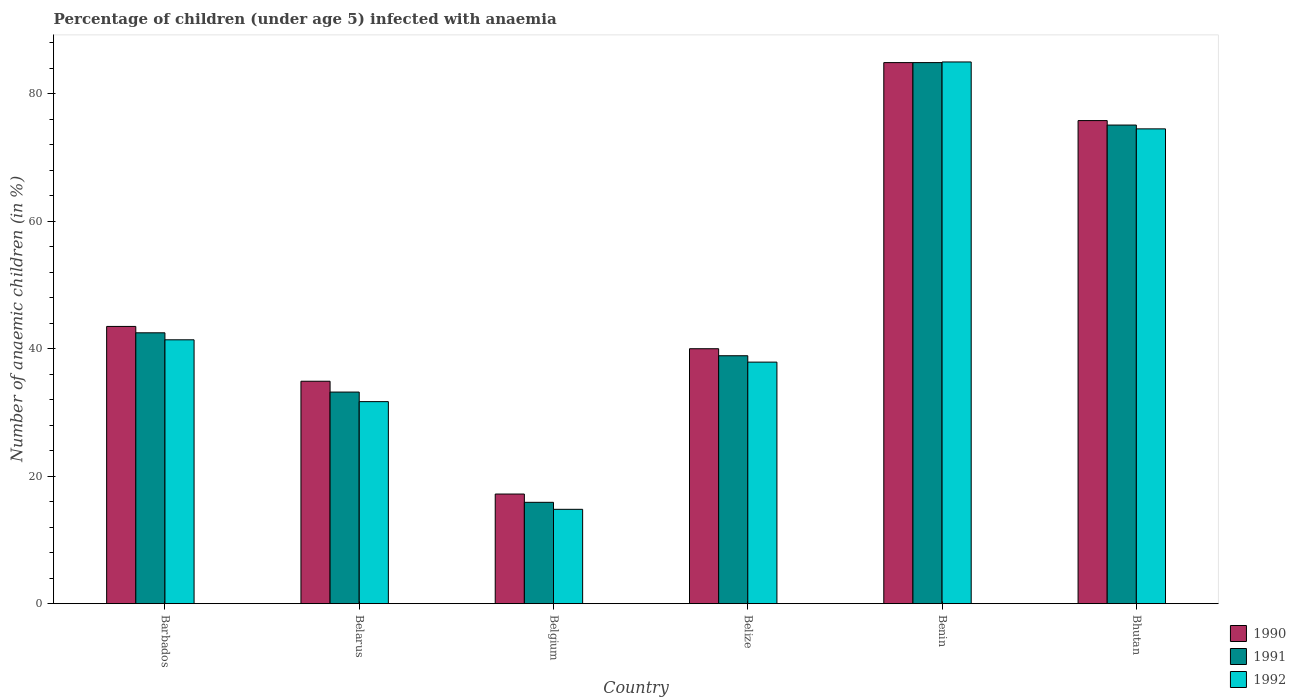How many different coloured bars are there?
Provide a short and direct response. 3. How many groups of bars are there?
Offer a very short reply. 6. Are the number of bars per tick equal to the number of legend labels?
Offer a terse response. Yes. How many bars are there on the 4th tick from the left?
Offer a terse response. 3. How many bars are there on the 4th tick from the right?
Your answer should be compact. 3. What is the label of the 2nd group of bars from the left?
Provide a succinct answer. Belarus. In how many cases, is the number of bars for a given country not equal to the number of legend labels?
Your answer should be very brief. 0. What is the percentage of children infected with anaemia in in 1991 in Belarus?
Provide a short and direct response. 33.2. Across all countries, what is the maximum percentage of children infected with anaemia in in 1991?
Your answer should be compact. 84.9. Across all countries, what is the minimum percentage of children infected with anaemia in in 1992?
Make the answer very short. 14.8. In which country was the percentage of children infected with anaemia in in 1990 maximum?
Provide a short and direct response. Benin. In which country was the percentage of children infected with anaemia in in 1992 minimum?
Offer a very short reply. Belgium. What is the total percentage of children infected with anaemia in in 1992 in the graph?
Your answer should be compact. 285.3. What is the difference between the percentage of children infected with anaemia in in 1992 in Barbados and that in Belarus?
Ensure brevity in your answer.  9.7. What is the difference between the percentage of children infected with anaemia in in 1992 in Bhutan and the percentage of children infected with anaemia in in 1990 in Benin?
Your answer should be very brief. -10.4. What is the average percentage of children infected with anaemia in in 1991 per country?
Offer a terse response. 48.42. What is the difference between the percentage of children infected with anaemia in of/in 1992 and percentage of children infected with anaemia in of/in 1990 in Belgium?
Offer a terse response. -2.4. What is the ratio of the percentage of children infected with anaemia in in 1992 in Belarus to that in Bhutan?
Give a very brief answer. 0.43. What is the difference between the highest and the second highest percentage of children infected with anaemia in in 1991?
Your answer should be compact. -32.6. What is the difference between the highest and the lowest percentage of children infected with anaemia in in 1991?
Ensure brevity in your answer.  69. What does the 1st bar from the right in Benin represents?
Provide a succinct answer. 1992. How many bars are there?
Offer a very short reply. 18. Are all the bars in the graph horizontal?
Your answer should be compact. No. How many countries are there in the graph?
Your answer should be very brief. 6. Are the values on the major ticks of Y-axis written in scientific E-notation?
Your answer should be compact. No. Does the graph contain grids?
Your answer should be very brief. No. How many legend labels are there?
Offer a very short reply. 3. What is the title of the graph?
Make the answer very short. Percentage of children (under age 5) infected with anaemia. What is the label or title of the Y-axis?
Your answer should be compact. Number of anaemic children (in %). What is the Number of anaemic children (in %) of 1990 in Barbados?
Provide a short and direct response. 43.5. What is the Number of anaemic children (in %) of 1991 in Barbados?
Offer a very short reply. 42.5. What is the Number of anaemic children (in %) in 1992 in Barbados?
Your response must be concise. 41.4. What is the Number of anaemic children (in %) of 1990 in Belarus?
Provide a succinct answer. 34.9. What is the Number of anaemic children (in %) of 1991 in Belarus?
Your response must be concise. 33.2. What is the Number of anaemic children (in %) in 1992 in Belarus?
Your answer should be very brief. 31.7. What is the Number of anaemic children (in %) of 1991 in Belgium?
Offer a very short reply. 15.9. What is the Number of anaemic children (in %) of 1992 in Belgium?
Provide a succinct answer. 14.8. What is the Number of anaemic children (in %) of 1990 in Belize?
Offer a very short reply. 40. What is the Number of anaemic children (in %) in 1991 in Belize?
Provide a succinct answer. 38.9. What is the Number of anaemic children (in %) of 1992 in Belize?
Provide a succinct answer. 37.9. What is the Number of anaemic children (in %) in 1990 in Benin?
Provide a succinct answer. 84.9. What is the Number of anaemic children (in %) in 1991 in Benin?
Your answer should be compact. 84.9. What is the Number of anaemic children (in %) of 1992 in Benin?
Make the answer very short. 85. What is the Number of anaemic children (in %) in 1990 in Bhutan?
Ensure brevity in your answer.  75.8. What is the Number of anaemic children (in %) in 1991 in Bhutan?
Ensure brevity in your answer.  75.1. What is the Number of anaemic children (in %) in 1992 in Bhutan?
Give a very brief answer. 74.5. Across all countries, what is the maximum Number of anaemic children (in %) of 1990?
Provide a short and direct response. 84.9. Across all countries, what is the maximum Number of anaemic children (in %) in 1991?
Ensure brevity in your answer.  84.9. Across all countries, what is the maximum Number of anaemic children (in %) of 1992?
Your response must be concise. 85. Across all countries, what is the minimum Number of anaemic children (in %) in 1990?
Make the answer very short. 17.2. Across all countries, what is the minimum Number of anaemic children (in %) in 1991?
Offer a terse response. 15.9. What is the total Number of anaemic children (in %) of 1990 in the graph?
Keep it short and to the point. 296.3. What is the total Number of anaemic children (in %) in 1991 in the graph?
Provide a succinct answer. 290.5. What is the total Number of anaemic children (in %) of 1992 in the graph?
Keep it short and to the point. 285.3. What is the difference between the Number of anaemic children (in %) of 1991 in Barbados and that in Belarus?
Ensure brevity in your answer.  9.3. What is the difference between the Number of anaemic children (in %) of 1992 in Barbados and that in Belarus?
Your response must be concise. 9.7. What is the difference between the Number of anaemic children (in %) of 1990 in Barbados and that in Belgium?
Make the answer very short. 26.3. What is the difference between the Number of anaemic children (in %) of 1991 in Barbados and that in Belgium?
Keep it short and to the point. 26.6. What is the difference between the Number of anaemic children (in %) in 1992 in Barbados and that in Belgium?
Your answer should be compact. 26.6. What is the difference between the Number of anaemic children (in %) of 1990 in Barbados and that in Belize?
Make the answer very short. 3.5. What is the difference between the Number of anaemic children (in %) in 1991 in Barbados and that in Belize?
Your answer should be compact. 3.6. What is the difference between the Number of anaemic children (in %) of 1990 in Barbados and that in Benin?
Provide a short and direct response. -41.4. What is the difference between the Number of anaemic children (in %) in 1991 in Barbados and that in Benin?
Keep it short and to the point. -42.4. What is the difference between the Number of anaemic children (in %) in 1992 in Barbados and that in Benin?
Offer a terse response. -43.6. What is the difference between the Number of anaemic children (in %) in 1990 in Barbados and that in Bhutan?
Make the answer very short. -32.3. What is the difference between the Number of anaemic children (in %) of 1991 in Barbados and that in Bhutan?
Give a very brief answer. -32.6. What is the difference between the Number of anaemic children (in %) of 1992 in Barbados and that in Bhutan?
Offer a very short reply. -33.1. What is the difference between the Number of anaemic children (in %) of 1991 in Belarus and that in Belgium?
Provide a short and direct response. 17.3. What is the difference between the Number of anaemic children (in %) of 1990 in Belarus and that in Belize?
Make the answer very short. -5.1. What is the difference between the Number of anaemic children (in %) of 1991 in Belarus and that in Benin?
Offer a very short reply. -51.7. What is the difference between the Number of anaemic children (in %) of 1992 in Belarus and that in Benin?
Your response must be concise. -53.3. What is the difference between the Number of anaemic children (in %) of 1990 in Belarus and that in Bhutan?
Make the answer very short. -40.9. What is the difference between the Number of anaemic children (in %) in 1991 in Belarus and that in Bhutan?
Make the answer very short. -41.9. What is the difference between the Number of anaemic children (in %) in 1992 in Belarus and that in Bhutan?
Make the answer very short. -42.8. What is the difference between the Number of anaemic children (in %) of 1990 in Belgium and that in Belize?
Give a very brief answer. -22.8. What is the difference between the Number of anaemic children (in %) in 1992 in Belgium and that in Belize?
Offer a terse response. -23.1. What is the difference between the Number of anaemic children (in %) in 1990 in Belgium and that in Benin?
Provide a succinct answer. -67.7. What is the difference between the Number of anaemic children (in %) of 1991 in Belgium and that in Benin?
Provide a succinct answer. -69. What is the difference between the Number of anaemic children (in %) of 1992 in Belgium and that in Benin?
Provide a short and direct response. -70.2. What is the difference between the Number of anaemic children (in %) in 1990 in Belgium and that in Bhutan?
Offer a very short reply. -58.6. What is the difference between the Number of anaemic children (in %) in 1991 in Belgium and that in Bhutan?
Ensure brevity in your answer.  -59.2. What is the difference between the Number of anaemic children (in %) of 1992 in Belgium and that in Bhutan?
Your response must be concise. -59.7. What is the difference between the Number of anaemic children (in %) in 1990 in Belize and that in Benin?
Your answer should be compact. -44.9. What is the difference between the Number of anaemic children (in %) in 1991 in Belize and that in Benin?
Your answer should be compact. -46. What is the difference between the Number of anaemic children (in %) in 1992 in Belize and that in Benin?
Your response must be concise. -47.1. What is the difference between the Number of anaemic children (in %) in 1990 in Belize and that in Bhutan?
Offer a terse response. -35.8. What is the difference between the Number of anaemic children (in %) in 1991 in Belize and that in Bhutan?
Give a very brief answer. -36.2. What is the difference between the Number of anaemic children (in %) in 1992 in Belize and that in Bhutan?
Give a very brief answer. -36.6. What is the difference between the Number of anaemic children (in %) in 1990 in Benin and that in Bhutan?
Keep it short and to the point. 9.1. What is the difference between the Number of anaemic children (in %) of 1992 in Benin and that in Bhutan?
Offer a terse response. 10.5. What is the difference between the Number of anaemic children (in %) of 1990 in Barbados and the Number of anaemic children (in %) of 1992 in Belarus?
Your answer should be compact. 11.8. What is the difference between the Number of anaemic children (in %) in 1991 in Barbados and the Number of anaemic children (in %) in 1992 in Belarus?
Offer a terse response. 10.8. What is the difference between the Number of anaemic children (in %) in 1990 in Barbados and the Number of anaemic children (in %) in 1991 in Belgium?
Provide a short and direct response. 27.6. What is the difference between the Number of anaemic children (in %) in 1990 in Barbados and the Number of anaemic children (in %) in 1992 in Belgium?
Give a very brief answer. 28.7. What is the difference between the Number of anaemic children (in %) in 1991 in Barbados and the Number of anaemic children (in %) in 1992 in Belgium?
Your answer should be compact. 27.7. What is the difference between the Number of anaemic children (in %) of 1990 in Barbados and the Number of anaemic children (in %) of 1991 in Belize?
Offer a terse response. 4.6. What is the difference between the Number of anaemic children (in %) in 1991 in Barbados and the Number of anaemic children (in %) in 1992 in Belize?
Your answer should be very brief. 4.6. What is the difference between the Number of anaemic children (in %) in 1990 in Barbados and the Number of anaemic children (in %) in 1991 in Benin?
Provide a succinct answer. -41.4. What is the difference between the Number of anaemic children (in %) of 1990 in Barbados and the Number of anaemic children (in %) of 1992 in Benin?
Offer a very short reply. -41.5. What is the difference between the Number of anaemic children (in %) in 1991 in Barbados and the Number of anaemic children (in %) in 1992 in Benin?
Your response must be concise. -42.5. What is the difference between the Number of anaemic children (in %) of 1990 in Barbados and the Number of anaemic children (in %) of 1991 in Bhutan?
Offer a very short reply. -31.6. What is the difference between the Number of anaemic children (in %) in 1990 in Barbados and the Number of anaemic children (in %) in 1992 in Bhutan?
Offer a very short reply. -31. What is the difference between the Number of anaemic children (in %) of 1991 in Barbados and the Number of anaemic children (in %) of 1992 in Bhutan?
Offer a terse response. -32. What is the difference between the Number of anaemic children (in %) of 1990 in Belarus and the Number of anaemic children (in %) of 1992 in Belgium?
Offer a very short reply. 20.1. What is the difference between the Number of anaemic children (in %) of 1990 in Belarus and the Number of anaemic children (in %) of 1991 in Belize?
Your answer should be very brief. -4. What is the difference between the Number of anaemic children (in %) in 1990 in Belarus and the Number of anaemic children (in %) in 1992 in Belize?
Your answer should be very brief. -3. What is the difference between the Number of anaemic children (in %) of 1991 in Belarus and the Number of anaemic children (in %) of 1992 in Belize?
Give a very brief answer. -4.7. What is the difference between the Number of anaemic children (in %) in 1990 in Belarus and the Number of anaemic children (in %) in 1992 in Benin?
Offer a terse response. -50.1. What is the difference between the Number of anaemic children (in %) of 1991 in Belarus and the Number of anaemic children (in %) of 1992 in Benin?
Provide a succinct answer. -51.8. What is the difference between the Number of anaemic children (in %) in 1990 in Belarus and the Number of anaemic children (in %) in 1991 in Bhutan?
Offer a terse response. -40.2. What is the difference between the Number of anaemic children (in %) of 1990 in Belarus and the Number of anaemic children (in %) of 1992 in Bhutan?
Your answer should be very brief. -39.6. What is the difference between the Number of anaemic children (in %) in 1991 in Belarus and the Number of anaemic children (in %) in 1992 in Bhutan?
Provide a short and direct response. -41.3. What is the difference between the Number of anaemic children (in %) in 1990 in Belgium and the Number of anaemic children (in %) in 1991 in Belize?
Your response must be concise. -21.7. What is the difference between the Number of anaemic children (in %) in 1990 in Belgium and the Number of anaemic children (in %) in 1992 in Belize?
Your answer should be very brief. -20.7. What is the difference between the Number of anaemic children (in %) in 1991 in Belgium and the Number of anaemic children (in %) in 1992 in Belize?
Provide a succinct answer. -22. What is the difference between the Number of anaemic children (in %) of 1990 in Belgium and the Number of anaemic children (in %) of 1991 in Benin?
Your answer should be very brief. -67.7. What is the difference between the Number of anaemic children (in %) of 1990 in Belgium and the Number of anaemic children (in %) of 1992 in Benin?
Give a very brief answer. -67.8. What is the difference between the Number of anaemic children (in %) in 1991 in Belgium and the Number of anaemic children (in %) in 1992 in Benin?
Your answer should be compact. -69.1. What is the difference between the Number of anaemic children (in %) in 1990 in Belgium and the Number of anaemic children (in %) in 1991 in Bhutan?
Ensure brevity in your answer.  -57.9. What is the difference between the Number of anaemic children (in %) in 1990 in Belgium and the Number of anaemic children (in %) in 1992 in Bhutan?
Give a very brief answer. -57.3. What is the difference between the Number of anaemic children (in %) in 1991 in Belgium and the Number of anaemic children (in %) in 1992 in Bhutan?
Provide a succinct answer. -58.6. What is the difference between the Number of anaemic children (in %) in 1990 in Belize and the Number of anaemic children (in %) in 1991 in Benin?
Ensure brevity in your answer.  -44.9. What is the difference between the Number of anaemic children (in %) in 1990 in Belize and the Number of anaemic children (in %) in 1992 in Benin?
Your answer should be compact. -45. What is the difference between the Number of anaemic children (in %) in 1991 in Belize and the Number of anaemic children (in %) in 1992 in Benin?
Your answer should be compact. -46.1. What is the difference between the Number of anaemic children (in %) in 1990 in Belize and the Number of anaemic children (in %) in 1991 in Bhutan?
Provide a succinct answer. -35.1. What is the difference between the Number of anaemic children (in %) in 1990 in Belize and the Number of anaemic children (in %) in 1992 in Bhutan?
Ensure brevity in your answer.  -34.5. What is the difference between the Number of anaemic children (in %) in 1991 in Belize and the Number of anaemic children (in %) in 1992 in Bhutan?
Offer a terse response. -35.6. What is the difference between the Number of anaemic children (in %) of 1990 in Benin and the Number of anaemic children (in %) of 1992 in Bhutan?
Offer a very short reply. 10.4. What is the difference between the Number of anaemic children (in %) in 1991 in Benin and the Number of anaemic children (in %) in 1992 in Bhutan?
Make the answer very short. 10.4. What is the average Number of anaemic children (in %) of 1990 per country?
Your response must be concise. 49.38. What is the average Number of anaemic children (in %) in 1991 per country?
Your answer should be very brief. 48.42. What is the average Number of anaemic children (in %) in 1992 per country?
Your answer should be compact. 47.55. What is the difference between the Number of anaemic children (in %) of 1990 and Number of anaemic children (in %) of 1991 in Belarus?
Your answer should be compact. 1.7. What is the difference between the Number of anaemic children (in %) of 1990 and Number of anaemic children (in %) of 1992 in Belgium?
Your answer should be compact. 2.4. What is the difference between the Number of anaemic children (in %) of 1991 and Number of anaemic children (in %) of 1992 in Belgium?
Provide a short and direct response. 1.1. What is the difference between the Number of anaemic children (in %) of 1990 and Number of anaemic children (in %) of 1992 in Belize?
Your response must be concise. 2.1. What is the difference between the Number of anaemic children (in %) in 1990 and Number of anaemic children (in %) in 1992 in Benin?
Your response must be concise. -0.1. What is the difference between the Number of anaemic children (in %) in 1991 and Number of anaemic children (in %) in 1992 in Bhutan?
Provide a short and direct response. 0.6. What is the ratio of the Number of anaemic children (in %) in 1990 in Barbados to that in Belarus?
Your response must be concise. 1.25. What is the ratio of the Number of anaemic children (in %) in 1991 in Barbados to that in Belarus?
Provide a short and direct response. 1.28. What is the ratio of the Number of anaemic children (in %) of 1992 in Barbados to that in Belarus?
Provide a succinct answer. 1.31. What is the ratio of the Number of anaemic children (in %) in 1990 in Barbados to that in Belgium?
Your answer should be very brief. 2.53. What is the ratio of the Number of anaemic children (in %) in 1991 in Barbados to that in Belgium?
Provide a short and direct response. 2.67. What is the ratio of the Number of anaemic children (in %) in 1992 in Barbados to that in Belgium?
Keep it short and to the point. 2.8. What is the ratio of the Number of anaemic children (in %) of 1990 in Barbados to that in Belize?
Ensure brevity in your answer.  1.09. What is the ratio of the Number of anaemic children (in %) of 1991 in Barbados to that in Belize?
Provide a succinct answer. 1.09. What is the ratio of the Number of anaemic children (in %) in 1992 in Barbados to that in Belize?
Your response must be concise. 1.09. What is the ratio of the Number of anaemic children (in %) in 1990 in Barbados to that in Benin?
Your answer should be very brief. 0.51. What is the ratio of the Number of anaemic children (in %) of 1991 in Barbados to that in Benin?
Offer a terse response. 0.5. What is the ratio of the Number of anaemic children (in %) in 1992 in Barbados to that in Benin?
Make the answer very short. 0.49. What is the ratio of the Number of anaemic children (in %) of 1990 in Barbados to that in Bhutan?
Your answer should be very brief. 0.57. What is the ratio of the Number of anaemic children (in %) of 1991 in Barbados to that in Bhutan?
Your response must be concise. 0.57. What is the ratio of the Number of anaemic children (in %) of 1992 in Barbados to that in Bhutan?
Offer a very short reply. 0.56. What is the ratio of the Number of anaemic children (in %) in 1990 in Belarus to that in Belgium?
Make the answer very short. 2.03. What is the ratio of the Number of anaemic children (in %) of 1991 in Belarus to that in Belgium?
Your answer should be very brief. 2.09. What is the ratio of the Number of anaemic children (in %) of 1992 in Belarus to that in Belgium?
Offer a terse response. 2.14. What is the ratio of the Number of anaemic children (in %) in 1990 in Belarus to that in Belize?
Make the answer very short. 0.87. What is the ratio of the Number of anaemic children (in %) of 1991 in Belarus to that in Belize?
Ensure brevity in your answer.  0.85. What is the ratio of the Number of anaemic children (in %) in 1992 in Belarus to that in Belize?
Offer a very short reply. 0.84. What is the ratio of the Number of anaemic children (in %) in 1990 in Belarus to that in Benin?
Make the answer very short. 0.41. What is the ratio of the Number of anaemic children (in %) in 1991 in Belarus to that in Benin?
Provide a succinct answer. 0.39. What is the ratio of the Number of anaemic children (in %) of 1992 in Belarus to that in Benin?
Your response must be concise. 0.37. What is the ratio of the Number of anaemic children (in %) of 1990 in Belarus to that in Bhutan?
Your response must be concise. 0.46. What is the ratio of the Number of anaemic children (in %) of 1991 in Belarus to that in Bhutan?
Your response must be concise. 0.44. What is the ratio of the Number of anaemic children (in %) in 1992 in Belarus to that in Bhutan?
Your answer should be compact. 0.43. What is the ratio of the Number of anaemic children (in %) of 1990 in Belgium to that in Belize?
Offer a very short reply. 0.43. What is the ratio of the Number of anaemic children (in %) in 1991 in Belgium to that in Belize?
Your answer should be compact. 0.41. What is the ratio of the Number of anaemic children (in %) in 1992 in Belgium to that in Belize?
Provide a succinct answer. 0.39. What is the ratio of the Number of anaemic children (in %) in 1990 in Belgium to that in Benin?
Provide a succinct answer. 0.2. What is the ratio of the Number of anaemic children (in %) of 1991 in Belgium to that in Benin?
Make the answer very short. 0.19. What is the ratio of the Number of anaemic children (in %) in 1992 in Belgium to that in Benin?
Offer a terse response. 0.17. What is the ratio of the Number of anaemic children (in %) of 1990 in Belgium to that in Bhutan?
Ensure brevity in your answer.  0.23. What is the ratio of the Number of anaemic children (in %) in 1991 in Belgium to that in Bhutan?
Provide a succinct answer. 0.21. What is the ratio of the Number of anaemic children (in %) of 1992 in Belgium to that in Bhutan?
Provide a short and direct response. 0.2. What is the ratio of the Number of anaemic children (in %) of 1990 in Belize to that in Benin?
Ensure brevity in your answer.  0.47. What is the ratio of the Number of anaemic children (in %) of 1991 in Belize to that in Benin?
Provide a short and direct response. 0.46. What is the ratio of the Number of anaemic children (in %) of 1992 in Belize to that in Benin?
Offer a very short reply. 0.45. What is the ratio of the Number of anaemic children (in %) in 1990 in Belize to that in Bhutan?
Make the answer very short. 0.53. What is the ratio of the Number of anaemic children (in %) of 1991 in Belize to that in Bhutan?
Your answer should be very brief. 0.52. What is the ratio of the Number of anaemic children (in %) in 1992 in Belize to that in Bhutan?
Your response must be concise. 0.51. What is the ratio of the Number of anaemic children (in %) in 1990 in Benin to that in Bhutan?
Make the answer very short. 1.12. What is the ratio of the Number of anaemic children (in %) of 1991 in Benin to that in Bhutan?
Your answer should be very brief. 1.13. What is the ratio of the Number of anaemic children (in %) in 1992 in Benin to that in Bhutan?
Ensure brevity in your answer.  1.14. What is the difference between the highest and the second highest Number of anaemic children (in %) in 1990?
Your answer should be very brief. 9.1. What is the difference between the highest and the lowest Number of anaemic children (in %) in 1990?
Your answer should be compact. 67.7. What is the difference between the highest and the lowest Number of anaemic children (in %) in 1992?
Offer a very short reply. 70.2. 